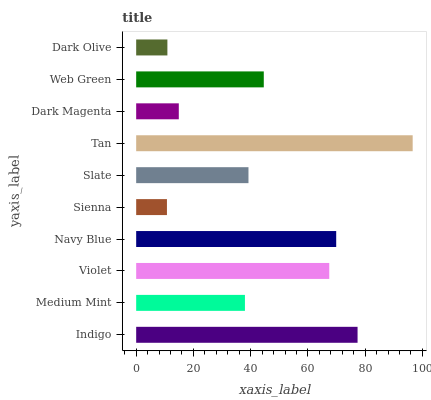Is Sienna the minimum?
Answer yes or no. Yes. Is Tan the maximum?
Answer yes or no. Yes. Is Medium Mint the minimum?
Answer yes or no. No. Is Medium Mint the maximum?
Answer yes or no. No. Is Indigo greater than Medium Mint?
Answer yes or no. Yes. Is Medium Mint less than Indigo?
Answer yes or no. Yes. Is Medium Mint greater than Indigo?
Answer yes or no. No. Is Indigo less than Medium Mint?
Answer yes or no. No. Is Web Green the high median?
Answer yes or no. Yes. Is Slate the low median?
Answer yes or no. Yes. Is Sienna the high median?
Answer yes or no. No. Is Violet the low median?
Answer yes or no. No. 